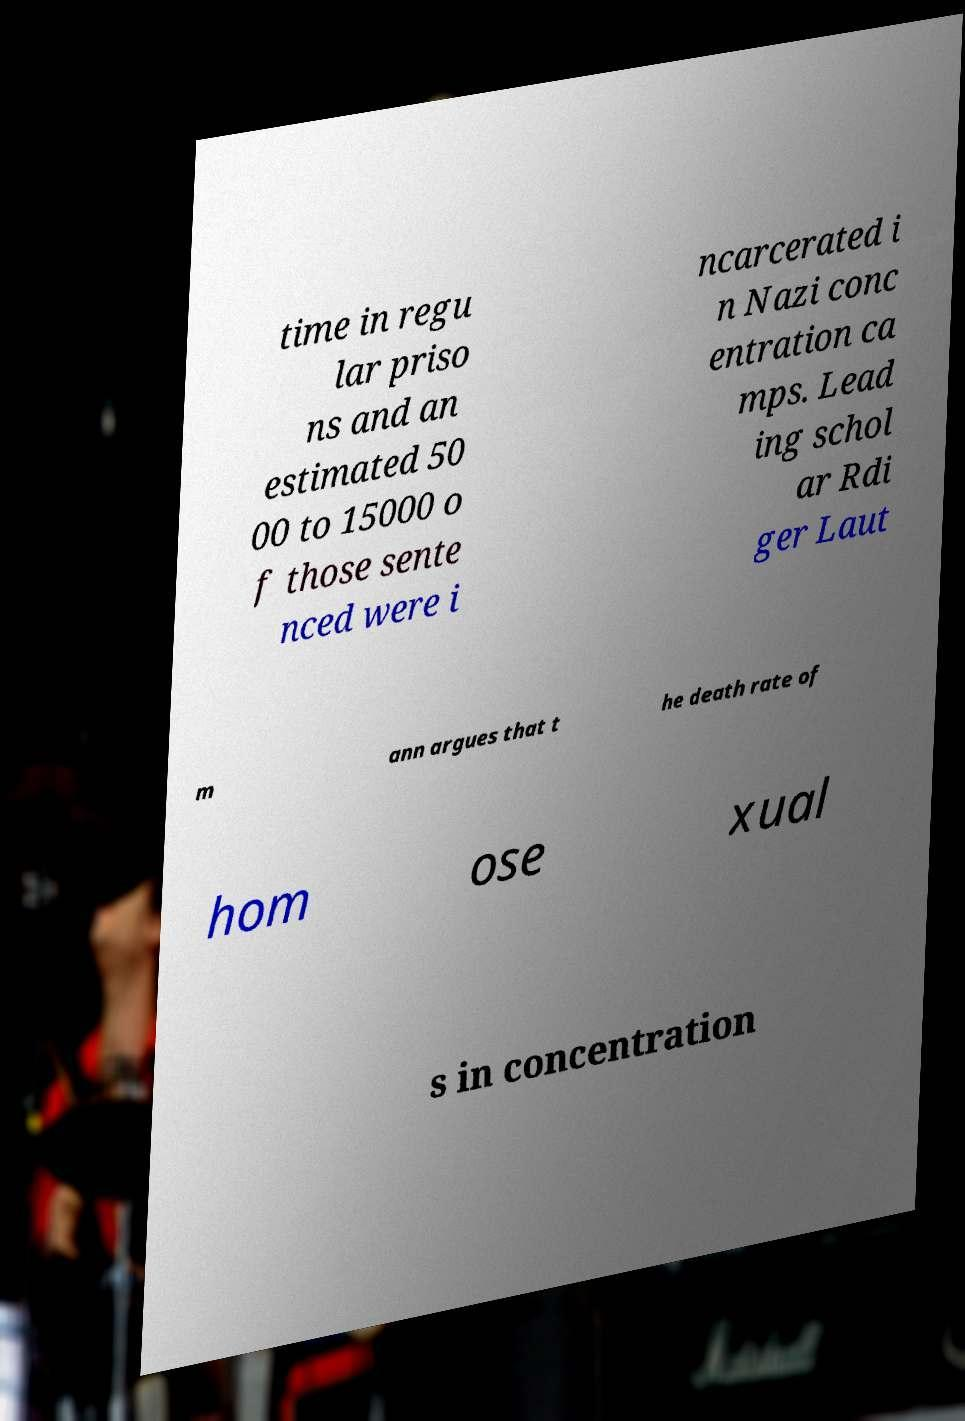Please read and relay the text visible in this image. What does it say? time in regu lar priso ns and an estimated 50 00 to 15000 o f those sente nced were i ncarcerated i n Nazi conc entration ca mps. Lead ing schol ar Rdi ger Laut m ann argues that t he death rate of hom ose xual s in concentration 